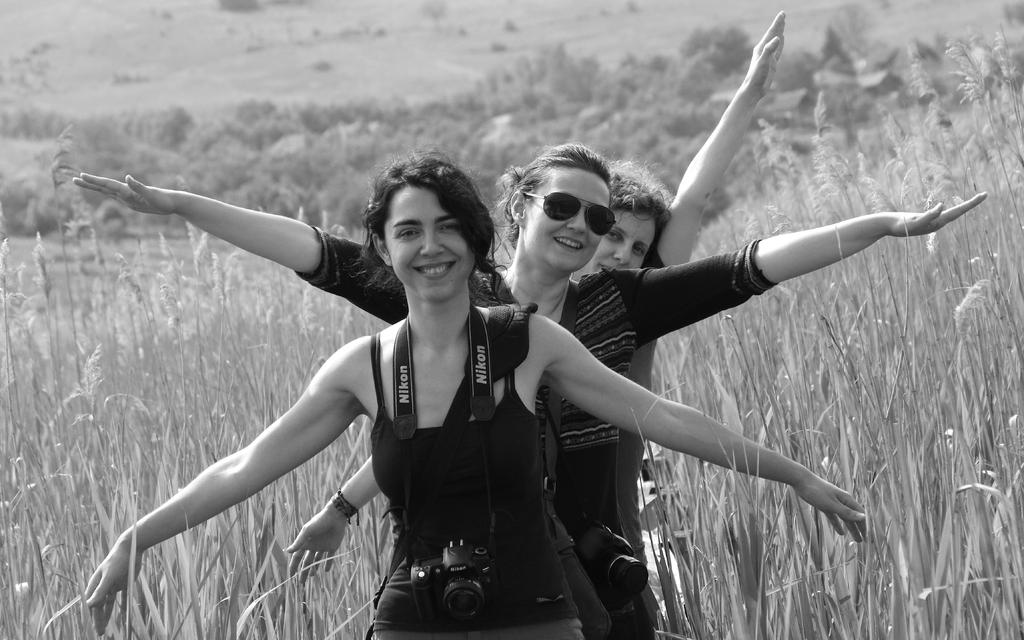How many people are in the image? There are three people in the image. Where are the people located in the image? The people are standing on a path in the image. What can be seen in the background of the image? There are trees and grass visible in the background of the image. What type of circle is being discussed by the people in the image? There is no circle or discussion about a circle present in the image. 